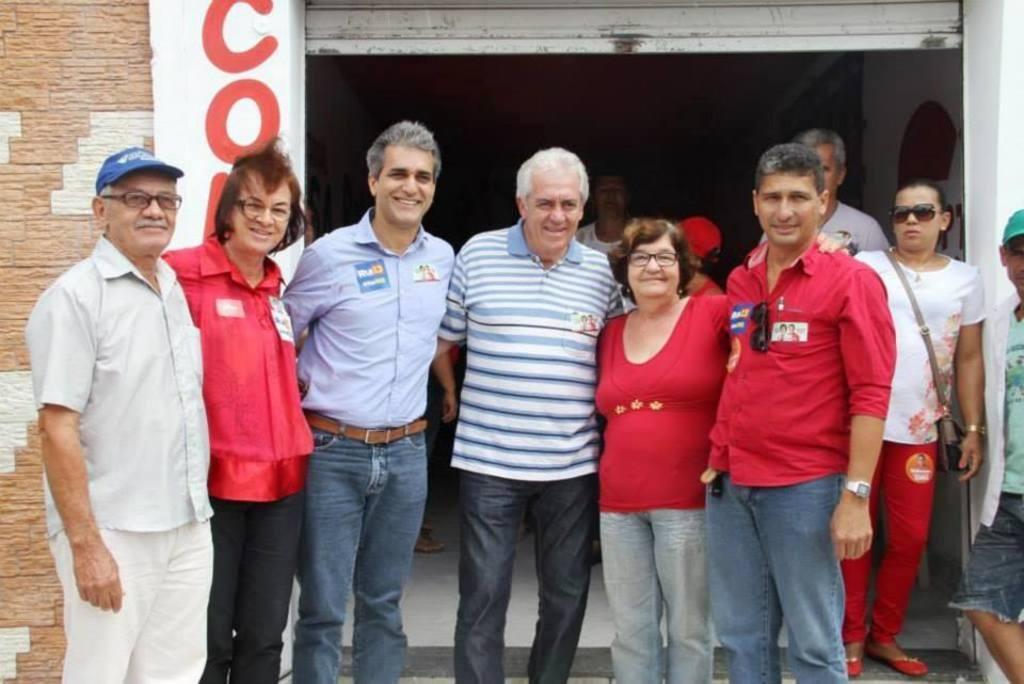In one or two sentences, can you explain what this image depicts? In this image there are persons standing and smiling. In the background there is a wall and on the wall there is some text which is visible and there are persons standing in the background. 